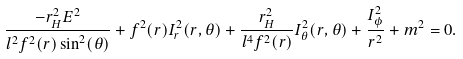<formula> <loc_0><loc_0><loc_500><loc_500>\frac { - r _ { H } ^ { 2 } E ^ { 2 } } { l ^ { 2 } f ^ { 2 } ( r ) \sin ^ { 2 } ( \theta ) } + f ^ { 2 } ( r ) I _ { r } ^ { 2 } ( r , \theta ) + \frac { r _ { H } ^ { 2 } } { l ^ { 4 } f ^ { 2 } ( r ) } I _ { \theta } ^ { 2 } ( r , \theta ) + \frac { I _ { \phi } ^ { 2 } } { r ^ { 2 } } + m ^ { 2 } = 0 .</formula> 